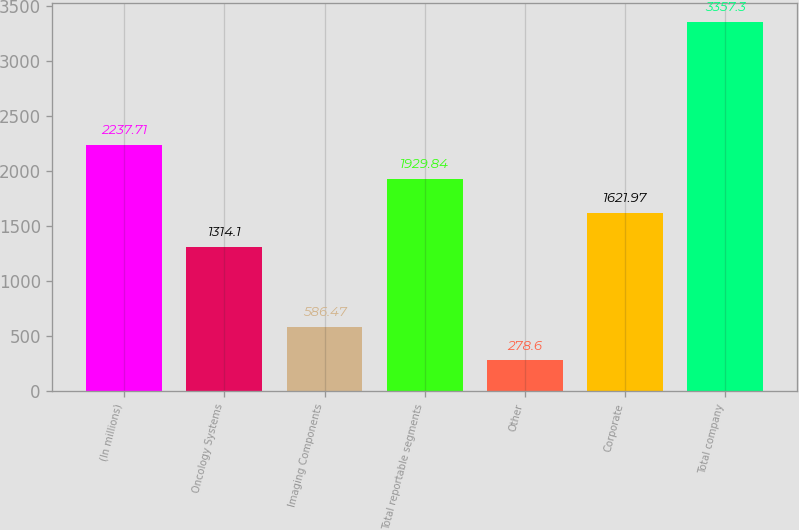Convert chart. <chart><loc_0><loc_0><loc_500><loc_500><bar_chart><fcel>(In millions)<fcel>Oncology Systems<fcel>Imaging Components<fcel>Total reportable segments<fcel>Other<fcel>Corporate<fcel>Total company<nl><fcel>2237.71<fcel>1314.1<fcel>586.47<fcel>1929.84<fcel>278.6<fcel>1621.97<fcel>3357.3<nl></chart> 